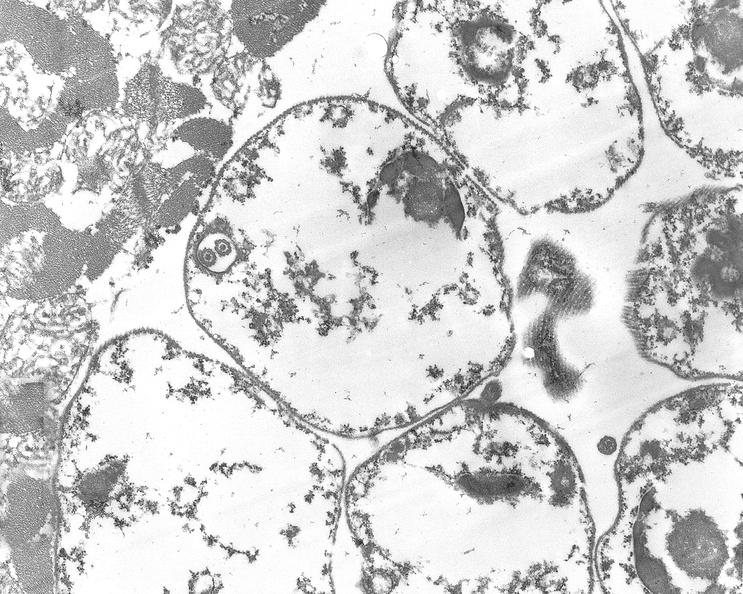what does this image show?
Answer the question using a single word or phrase. Chagas disease 